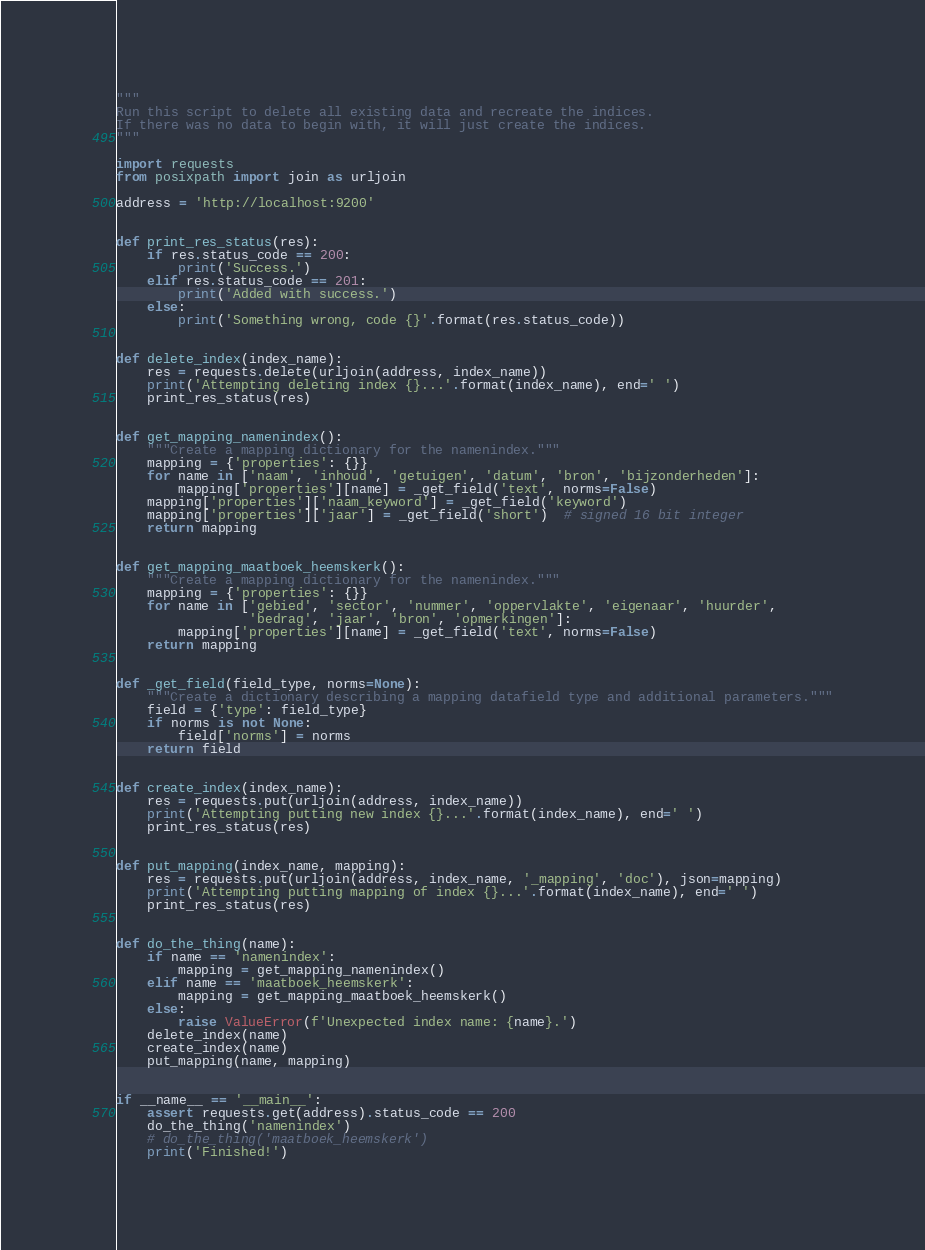Convert code to text. <code><loc_0><loc_0><loc_500><loc_500><_Python_>"""
Run this script to delete all existing data and recreate the indices.
If there was no data to begin with, it will just create the indices.
"""

import requests
from posixpath import join as urljoin

address = 'http://localhost:9200'


def print_res_status(res):
    if res.status_code == 200:
        print('Success.')
    elif res.status_code == 201:
        print('Added with success.')
    else:
        print('Something wrong, code {}'.format(res.status_code))


def delete_index(index_name):
    res = requests.delete(urljoin(address, index_name))
    print('Attempting deleting index {}...'.format(index_name), end=' ')
    print_res_status(res)


def get_mapping_namenindex():
    """Create a mapping dictionary for the namenindex."""
    mapping = {'properties': {}}
    for name in ['naam', 'inhoud', 'getuigen', 'datum', 'bron', 'bijzonderheden']:
        mapping['properties'][name] = _get_field('text', norms=False)
    mapping['properties']['naam_keyword'] = _get_field('keyword')
    mapping['properties']['jaar'] = _get_field('short')  # signed 16 bit integer
    return mapping


def get_mapping_maatboek_heemskerk():
    """Create a mapping dictionary for the namenindex."""
    mapping = {'properties': {}}
    for name in ['gebied', 'sector', 'nummer', 'oppervlakte', 'eigenaar', 'huurder',
                 'bedrag', 'jaar', 'bron', 'opmerkingen']:
        mapping['properties'][name] = _get_field('text', norms=False)
    return mapping


def _get_field(field_type, norms=None):
    """Create a dictionary describing a mapping datafield type and additional parameters."""
    field = {'type': field_type}
    if norms is not None:
        field['norms'] = norms
    return field


def create_index(index_name):
    res = requests.put(urljoin(address, index_name))
    print('Attempting putting new index {}...'.format(index_name), end=' ')
    print_res_status(res)


def put_mapping(index_name, mapping):
    res = requests.put(urljoin(address, index_name, '_mapping', 'doc'), json=mapping)
    print('Attempting putting mapping of index {}...'.format(index_name), end=' ')
    print_res_status(res)


def do_the_thing(name):
    if name == 'namenindex':
        mapping = get_mapping_namenindex()
    elif name == 'maatboek_heemskerk':
        mapping = get_mapping_maatboek_heemskerk()
    else:
        raise ValueError(f'Unexpected index name: {name}.')
    delete_index(name)
    create_index(name)
    put_mapping(name, mapping)


if __name__ == '__main__':
    assert requests.get(address).status_code == 200
    do_the_thing('namenindex')
    # do_the_thing('maatboek_heemskerk')
    print('Finished!')
</code> 